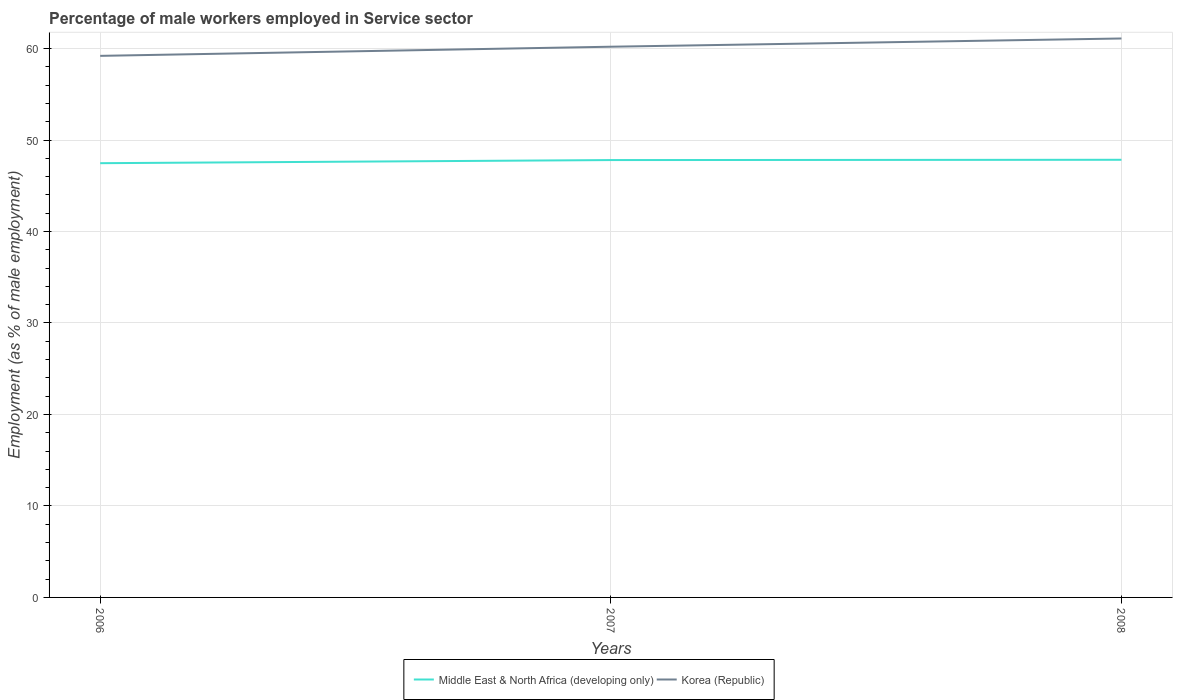How many different coloured lines are there?
Offer a terse response. 2. Does the line corresponding to Middle East & North Africa (developing only) intersect with the line corresponding to Korea (Republic)?
Your response must be concise. No. Across all years, what is the maximum percentage of male workers employed in Service sector in Korea (Republic)?
Your answer should be compact. 59.2. What is the total percentage of male workers employed in Service sector in Middle East & North Africa (developing only) in the graph?
Make the answer very short. -0.34. What is the difference between the highest and the second highest percentage of male workers employed in Service sector in Middle East & North Africa (developing only)?
Make the answer very short. 0.37. What is the difference between the highest and the lowest percentage of male workers employed in Service sector in Middle East & North Africa (developing only)?
Offer a very short reply. 2. What is the difference between two consecutive major ticks on the Y-axis?
Keep it short and to the point. 10. Are the values on the major ticks of Y-axis written in scientific E-notation?
Give a very brief answer. No. Does the graph contain any zero values?
Give a very brief answer. No. Where does the legend appear in the graph?
Offer a terse response. Bottom center. How many legend labels are there?
Your answer should be very brief. 2. What is the title of the graph?
Your answer should be compact. Percentage of male workers employed in Service sector. What is the label or title of the Y-axis?
Your response must be concise. Employment (as % of male employment). What is the Employment (as % of male employment) of Middle East & North Africa (developing only) in 2006?
Ensure brevity in your answer.  47.47. What is the Employment (as % of male employment) of Korea (Republic) in 2006?
Ensure brevity in your answer.  59.2. What is the Employment (as % of male employment) of Middle East & North Africa (developing only) in 2007?
Your answer should be compact. 47.81. What is the Employment (as % of male employment) of Korea (Republic) in 2007?
Give a very brief answer. 60.2. What is the Employment (as % of male employment) in Middle East & North Africa (developing only) in 2008?
Provide a short and direct response. 47.84. What is the Employment (as % of male employment) of Korea (Republic) in 2008?
Provide a succinct answer. 61.1. Across all years, what is the maximum Employment (as % of male employment) in Middle East & North Africa (developing only)?
Keep it short and to the point. 47.84. Across all years, what is the maximum Employment (as % of male employment) in Korea (Republic)?
Offer a very short reply. 61.1. Across all years, what is the minimum Employment (as % of male employment) in Middle East & North Africa (developing only)?
Provide a succinct answer. 47.47. Across all years, what is the minimum Employment (as % of male employment) of Korea (Republic)?
Your response must be concise. 59.2. What is the total Employment (as % of male employment) in Middle East & North Africa (developing only) in the graph?
Offer a terse response. 143.12. What is the total Employment (as % of male employment) of Korea (Republic) in the graph?
Offer a very short reply. 180.5. What is the difference between the Employment (as % of male employment) of Middle East & North Africa (developing only) in 2006 and that in 2007?
Your answer should be very brief. -0.34. What is the difference between the Employment (as % of male employment) in Middle East & North Africa (developing only) in 2006 and that in 2008?
Ensure brevity in your answer.  -0.37. What is the difference between the Employment (as % of male employment) of Middle East & North Africa (developing only) in 2007 and that in 2008?
Offer a terse response. -0.03. What is the difference between the Employment (as % of male employment) in Korea (Republic) in 2007 and that in 2008?
Your answer should be very brief. -0.9. What is the difference between the Employment (as % of male employment) in Middle East & North Africa (developing only) in 2006 and the Employment (as % of male employment) in Korea (Republic) in 2007?
Your answer should be very brief. -12.73. What is the difference between the Employment (as % of male employment) of Middle East & North Africa (developing only) in 2006 and the Employment (as % of male employment) of Korea (Republic) in 2008?
Offer a very short reply. -13.63. What is the difference between the Employment (as % of male employment) in Middle East & North Africa (developing only) in 2007 and the Employment (as % of male employment) in Korea (Republic) in 2008?
Offer a very short reply. -13.29. What is the average Employment (as % of male employment) in Middle East & North Africa (developing only) per year?
Give a very brief answer. 47.71. What is the average Employment (as % of male employment) of Korea (Republic) per year?
Make the answer very short. 60.17. In the year 2006, what is the difference between the Employment (as % of male employment) in Middle East & North Africa (developing only) and Employment (as % of male employment) in Korea (Republic)?
Provide a succinct answer. -11.73. In the year 2007, what is the difference between the Employment (as % of male employment) in Middle East & North Africa (developing only) and Employment (as % of male employment) in Korea (Republic)?
Provide a succinct answer. -12.39. In the year 2008, what is the difference between the Employment (as % of male employment) of Middle East & North Africa (developing only) and Employment (as % of male employment) of Korea (Republic)?
Offer a very short reply. -13.26. What is the ratio of the Employment (as % of male employment) in Korea (Republic) in 2006 to that in 2007?
Your answer should be very brief. 0.98. What is the ratio of the Employment (as % of male employment) in Middle East & North Africa (developing only) in 2006 to that in 2008?
Give a very brief answer. 0.99. What is the ratio of the Employment (as % of male employment) in Korea (Republic) in 2006 to that in 2008?
Make the answer very short. 0.97. What is the ratio of the Employment (as % of male employment) in Middle East & North Africa (developing only) in 2007 to that in 2008?
Provide a succinct answer. 1. What is the ratio of the Employment (as % of male employment) in Korea (Republic) in 2007 to that in 2008?
Offer a terse response. 0.99. What is the difference between the highest and the second highest Employment (as % of male employment) in Middle East & North Africa (developing only)?
Offer a terse response. 0.03. What is the difference between the highest and the lowest Employment (as % of male employment) in Middle East & North Africa (developing only)?
Provide a succinct answer. 0.37. 